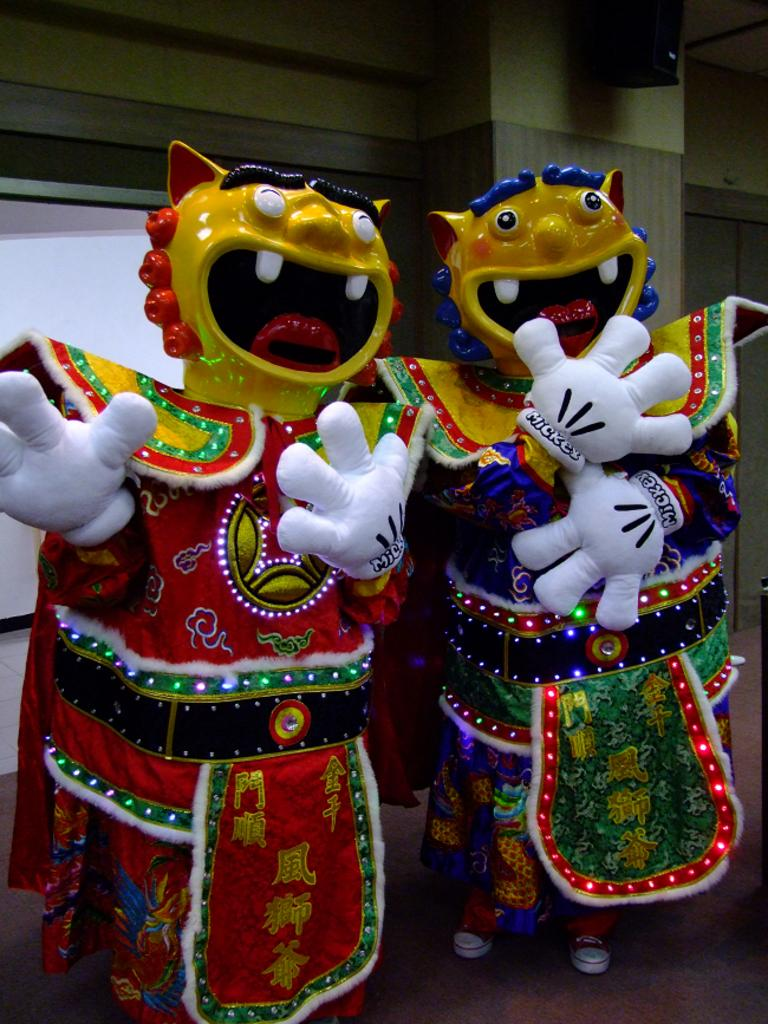What type of objects can be seen in the foreground of the image? There are miniature objects in the foreground of the image. What can be seen in the background of the image? There are boards and a wall in the background of the image. Can you describe the object that resembles a speaker? Yes, there is an object that looks like a speaker in the background of the image. What type of grain is being stored in the crate in the image? There is no crate or grain present in the image. How many fowl can be seen in the image? There are no fowl present in the image. 